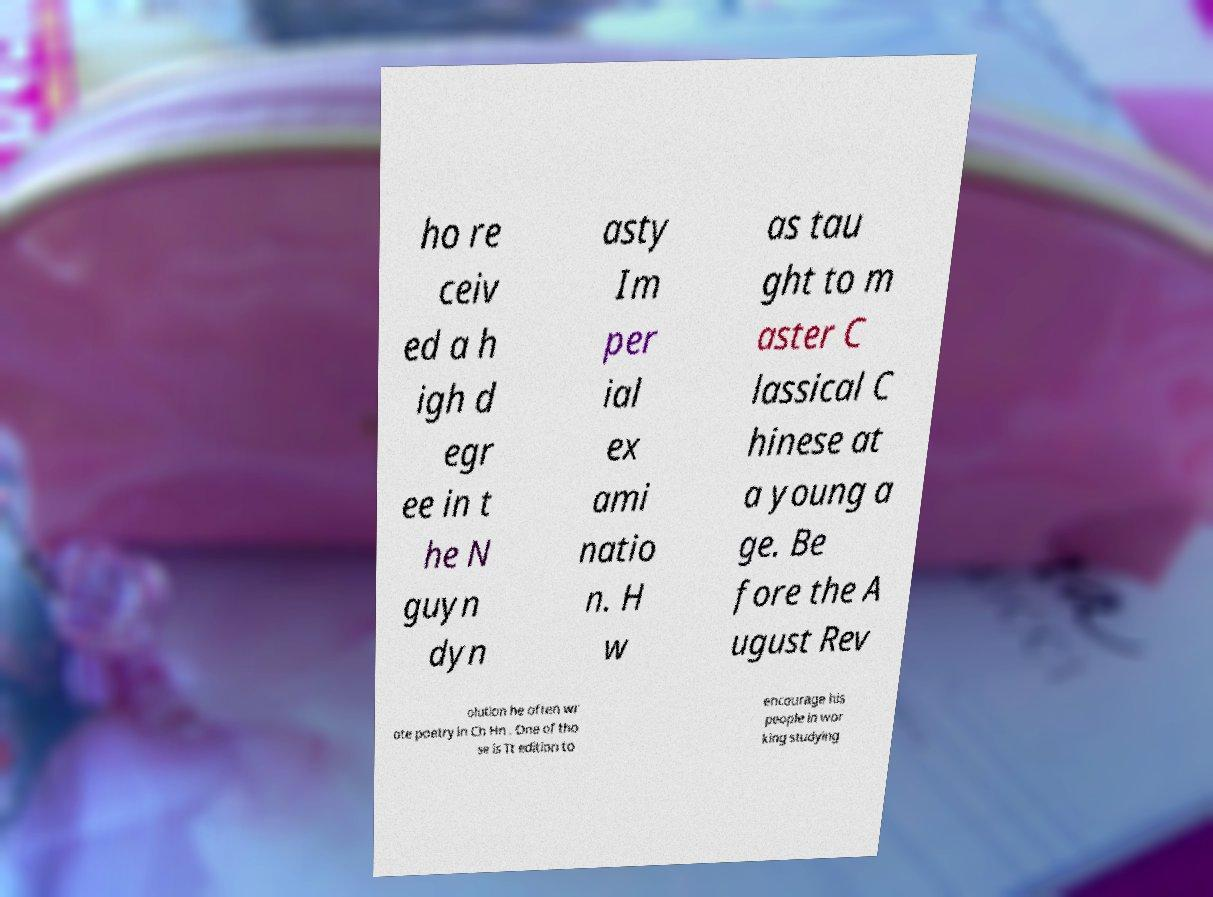Please read and relay the text visible in this image. What does it say? ho re ceiv ed a h igh d egr ee in t he N guyn dyn asty Im per ial ex ami natio n. H w as tau ght to m aster C lassical C hinese at a young a ge. Be fore the A ugust Rev olution he often wr ote poetry in Ch Hn . One of tho se is Tt edition to encourage his people in wor king studying 